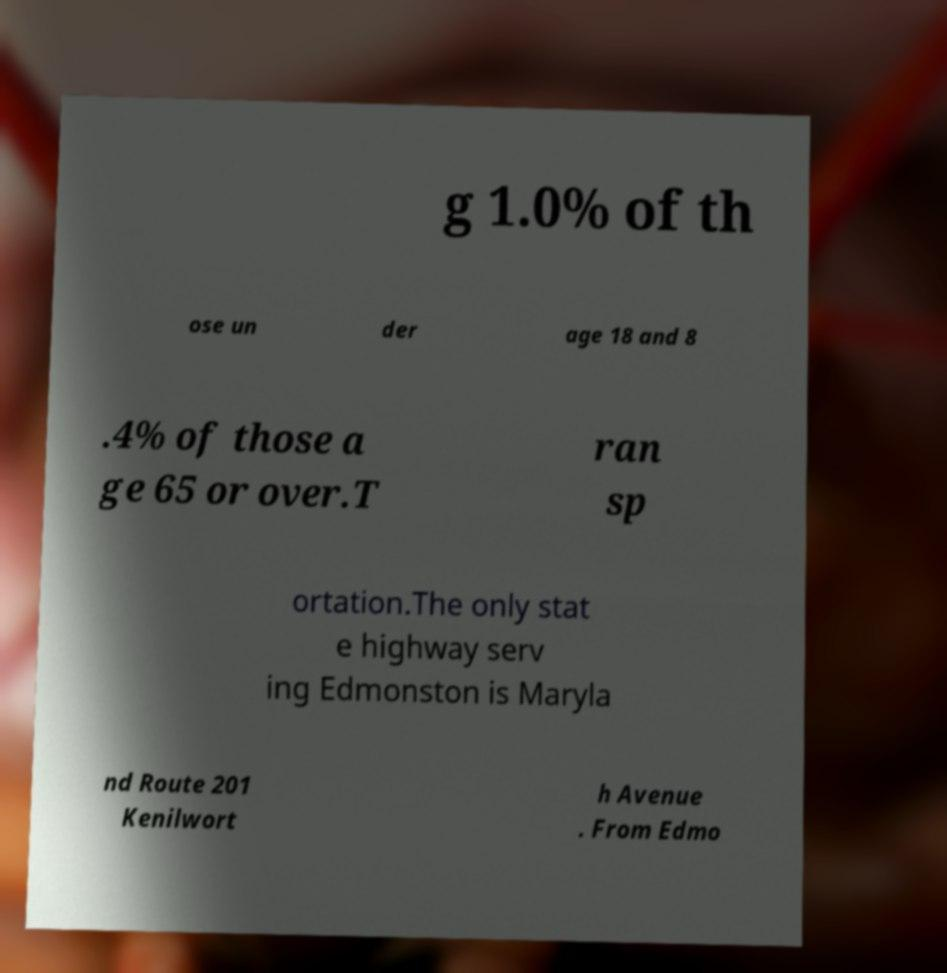There's text embedded in this image that I need extracted. Can you transcribe it verbatim? g 1.0% of th ose un der age 18 and 8 .4% of those a ge 65 or over.T ran sp ortation.The only stat e highway serv ing Edmonston is Maryla nd Route 201 Kenilwort h Avenue . From Edmo 